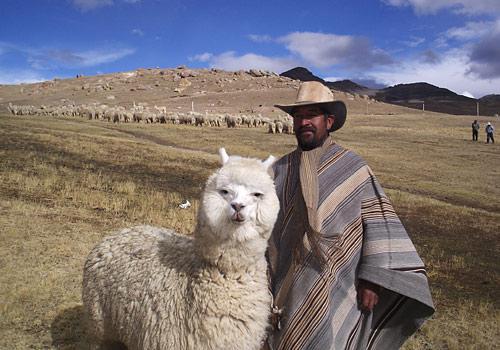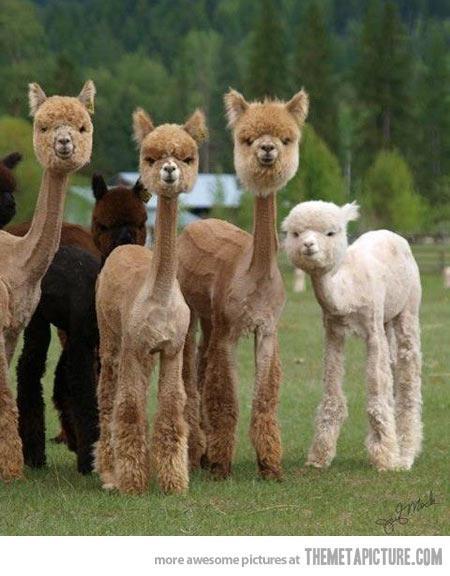The first image is the image on the left, the second image is the image on the right. Given the left and right images, does the statement "The foreground of the right image shows only camera-gazing llamas with solid colored fur." hold true? Answer yes or no. Yes. The first image is the image on the left, the second image is the image on the right. Examine the images to the left and right. Is the description "There are at least two alpacas one fully white and the other light brown facing and looking straight forward ." accurate? Answer yes or no. Yes. 